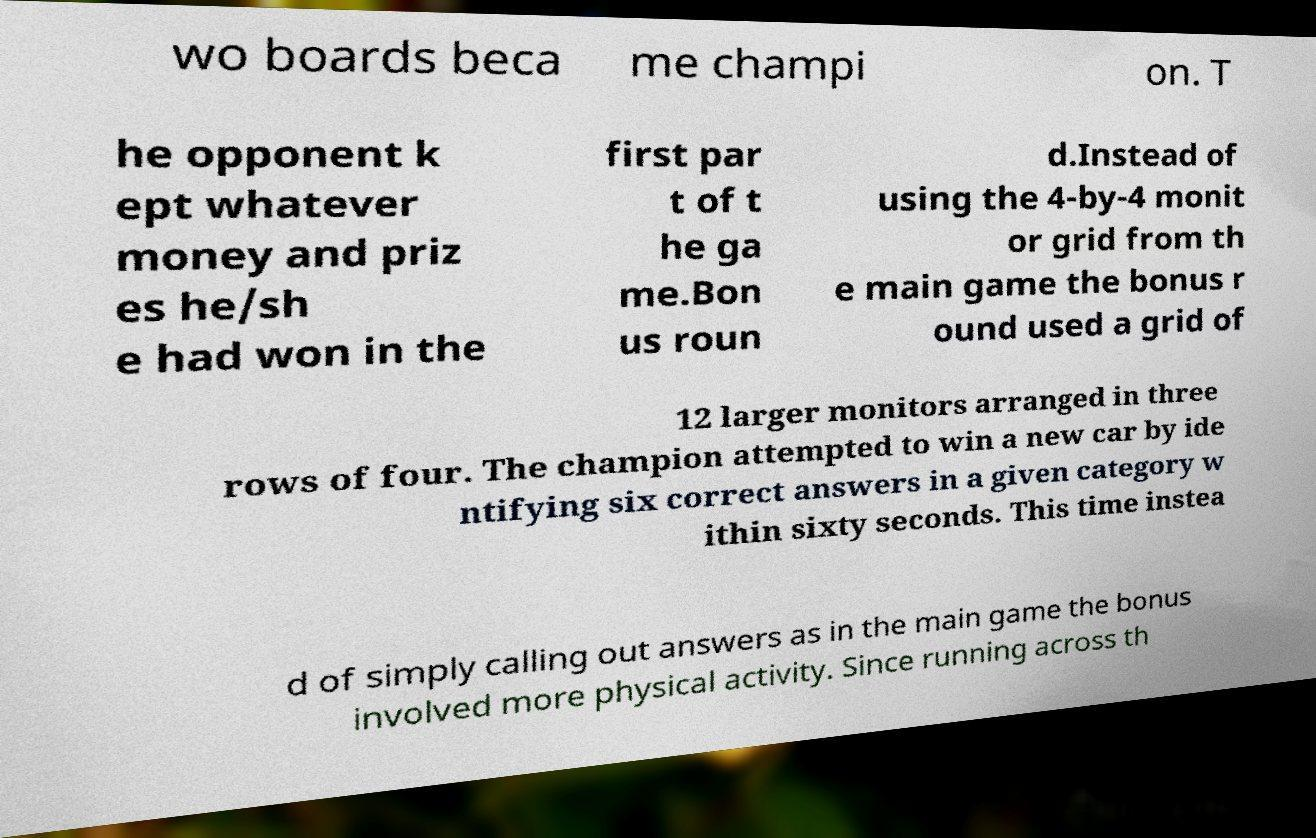Could you extract and type out the text from this image? wo boards beca me champi on. T he opponent k ept whatever money and priz es he/sh e had won in the first par t of t he ga me.Bon us roun d.Instead of using the 4-by-4 monit or grid from th e main game the bonus r ound used a grid of 12 larger monitors arranged in three rows of four. The champion attempted to win a new car by ide ntifying six correct answers in a given category w ithin sixty seconds. This time instea d of simply calling out answers as in the main game the bonus involved more physical activity. Since running across th 